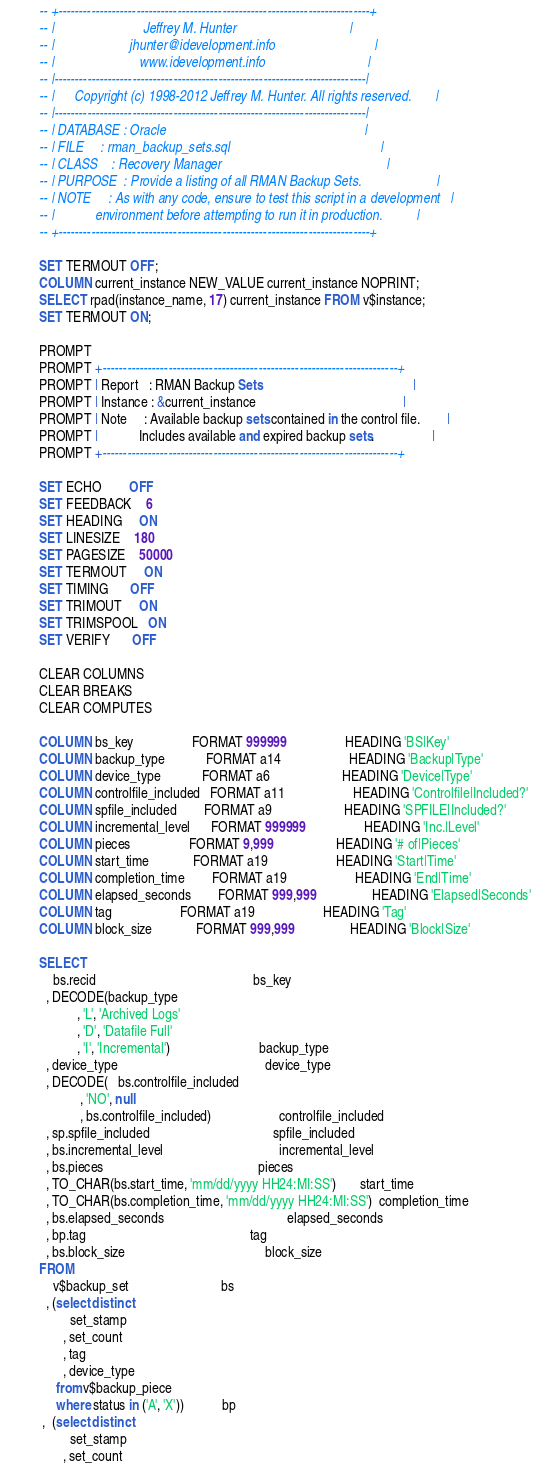Convert code to text. <code><loc_0><loc_0><loc_500><loc_500><_SQL_>-- +----------------------------------------------------------------------------+
-- |                          Jeffrey M. Hunter                                 |
-- |                      jhunter@idevelopment.info                             |
-- |                         www.idevelopment.info                              |
-- |----------------------------------------------------------------------------|
-- |      Copyright (c) 1998-2012 Jeffrey M. Hunter. All rights reserved.       |
-- |----------------------------------------------------------------------------|
-- | DATABASE : Oracle                                                          |
-- | FILE     : rman_backup_sets.sql                                            |
-- | CLASS    : Recovery Manager                                                |
-- | PURPOSE  : Provide a listing of all RMAN Backup Sets.                      |
-- | NOTE     : As with any code, ensure to test this script in a development   |
-- |            environment before attempting to run it in production.          |
-- +----------------------------------------------------------------------------+

SET TERMOUT OFF;
COLUMN current_instance NEW_VALUE current_instance NOPRINT;
SELECT rpad(instance_name, 17) current_instance FROM v$instance;
SET TERMOUT ON;

PROMPT 
PROMPT +------------------------------------------------------------------------+
PROMPT | Report   : RMAN Backup Sets                                            |
PROMPT | Instance : &current_instance                                           |
PROMPT | Note     : Available backup sets contained in the control file.        |
PROMPT |            Includes available and expired backup sets.                 |
PROMPT +------------------------------------------------------------------------+

SET ECHO        OFF
SET FEEDBACK    6
SET HEADING     ON
SET LINESIZE    180
SET PAGESIZE    50000
SET TERMOUT     ON
SET TIMING      OFF
SET TRIMOUT     ON
SET TRIMSPOOL   ON
SET VERIFY      OFF

CLEAR COLUMNS
CLEAR BREAKS
CLEAR COMPUTES

COLUMN bs_key                 FORMAT 999999                 HEADING 'BS|Key'
COLUMN backup_type            FORMAT a14                    HEADING 'Backup|Type'
COLUMN device_type            FORMAT a6                     HEADING 'Device|Type'
COLUMN controlfile_included   FORMAT a11                    HEADING 'Controlfile|Included?'
COLUMN spfile_included        FORMAT a9                     HEADING 'SPFILE|Included?'
COLUMN incremental_level      FORMAT 999999                 HEADING 'Inc.|Level'
COLUMN pieces                 FORMAT 9,999                  HEADING '# of|Pieces'
COLUMN start_time             FORMAT a19                    HEADING 'Start|Time'
COLUMN completion_time        FORMAT a19                    HEADING 'End|Time'
COLUMN elapsed_seconds        FORMAT 999,999                HEADING 'Elapsed|Seconds'
COLUMN tag                    FORMAT a19                    HEADING 'Tag'
COLUMN block_size             FORMAT 999,999                HEADING 'Block|Size'

SELECT
    bs.recid                                              bs_key
  , DECODE(backup_type
           , 'L', 'Archived Logs'
           , 'D', 'Datafile Full'
           , 'I', 'Incremental')                          backup_type
  , device_type                                           device_type
  , DECODE(   bs.controlfile_included
            , 'NO', null
            , bs.controlfile_included)                    controlfile_included
  , sp.spfile_included                                    spfile_included
  , bs.incremental_level                                  incremental_level
  , bs.pieces                                             pieces
  , TO_CHAR(bs.start_time, 'mm/dd/yyyy HH24:MI:SS')       start_time
  , TO_CHAR(bs.completion_time, 'mm/dd/yyyy HH24:MI:SS')  completion_time
  , bs.elapsed_seconds                                    elapsed_seconds
  , bp.tag                                                tag
  , bs.block_size                                         block_size
FROM
    v$backup_set                           bs
  , (select distinct
         set_stamp
       , set_count
       , tag
       , device_type
     from v$backup_piece
     where status in ('A', 'X'))           bp
 ,  (select distinct
         set_stamp
       , set_count</code> 